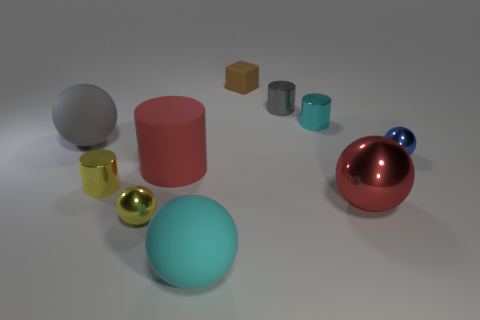Subtract all gray cylinders. How many cylinders are left? 3 Subtract all blocks. How many objects are left? 9 Subtract 2 cylinders. How many cylinders are left? 2 Subtract all cyan cylinders. Subtract all purple blocks. How many cylinders are left? 3 Subtract all cyan balls. How many red cylinders are left? 1 Subtract all matte blocks. Subtract all tiny gray objects. How many objects are left? 8 Add 3 cyan objects. How many cyan objects are left? 5 Add 2 large rubber things. How many large rubber things exist? 5 Subtract all red cylinders. How many cylinders are left? 3 Subtract 0 blue blocks. How many objects are left? 10 